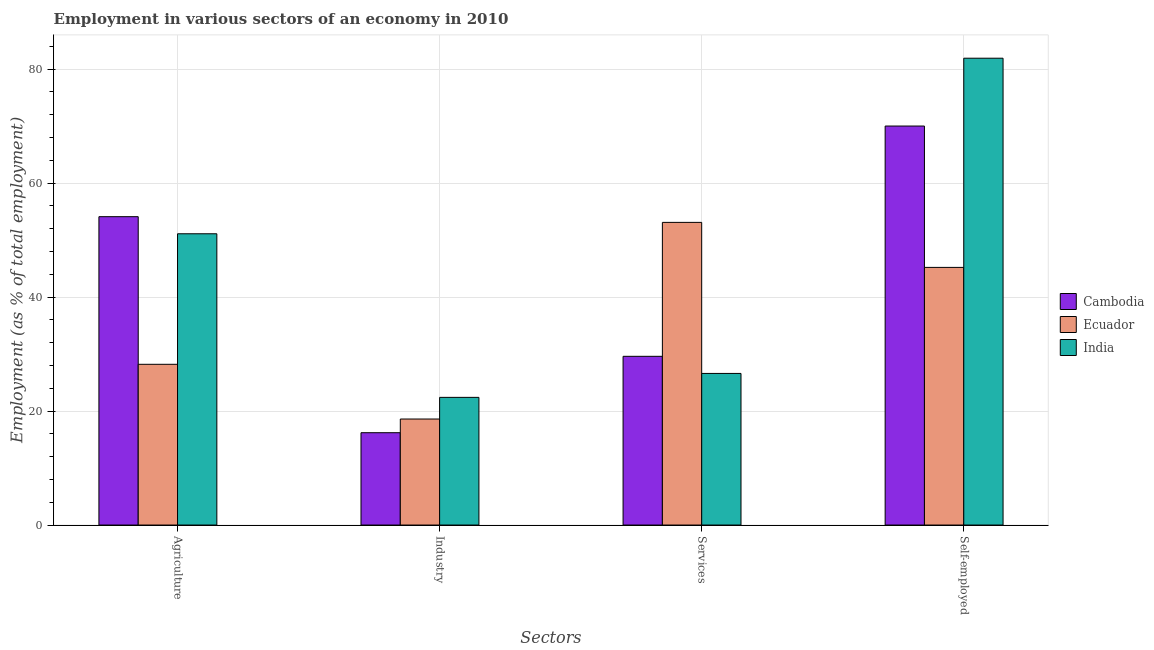How many different coloured bars are there?
Your answer should be very brief. 3. Are the number of bars on each tick of the X-axis equal?
Ensure brevity in your answer.  Yes. How many bars are there on the 1st tick from the left?
Your answer should be compact. 3. What is the label of the 2nd group of bars from the left?
Give a very brief answer. Industry. What is the percentage of self employed workers in Ecuador?
Keep it short and to the point. 45.2. Across all countries, what is the maximum percentage of self employed workers?
Offer a very short reply. 81.9. Across all countries, what is the minimum percentage of self employed workers?
Make the answer very short. 45.2. In which country was the percentage of workers in industry maximum?
Your answer should be very brief. India. In which country was the percentage of self employed workers minimum?
Make the answer very short. Ecuador. What is the total percentage of workers in agriculture in the graph?
Give a very brief answer. 133.4. What is the difference between the percentage of workers in agriculture in Ecuador and that in India?
Keep it short and to the point. -22.9. What is the difference between the percentage of self employed workers in Cambodia and the percentage of workers in industry in Ecuador?
Keep it short and to the point. 51.4. What is the average percentage of workers in agriculture per country?
Keep it short and to the point. 44.47. What is the difference between the percentage of workers in services and percentage of self employed workers in India?
Your answer should be very brief. -55.3. In how many countries, is the percentage of self employed workers greater than 20 %?
Make the answer very short. 3. What is the ratio of the percentage of workers in industry in Cambodia to that in Ecuador?
Provide a succinct answer. 0.87. Is the percentage of workers in agriculture in Cambodia less than that in Ecuador?
Keep it short and to the point. No. What is the difference between the highest and the second highest percentage of workers in agriculture?
Provide a short and direct response. 3. What is the difference between the highest and the lowest percentage of workers in services?
Your response must be concise. 26.5. In how many countries, is the percentage of workers in industry greater than the average percentage of workers in industry taken over all countries?
Your answer should be compact. 1. Is it the case that in every country, the sum of the percentage of workers in services and percentage of self employed workers is greater than the sum of percentage of workers in agriculture and percentage of workers in industry?
Ensure brevity in your answer.  Yes. What does the 3rd bar from the left in Self-employed represents?
Your answer should be very brief. India. Is it the case that in every country, the sum of the percentage of workers in agriculture and percentage of workers in industry is greater than the percentage of workers in services?
Provide a succinct answer. No. How many bars are there?
Provide a short and direct response. 12. How many countries are there in the graph?
Your answer should be very brief. 3. Are the values on the major ticks of Y-axis written in scientific E-notation?
Keep it short and to the point. No. Does the graph contain any zero values?
Your answer should be very brief. No. Does the graph contain grids?
Keep it short and to the point. Yes. Where does the legend appear in the graph?
Your answer should be compact. Center right. How many legend labels are there?
Your answer should be very brief. 3. How are the legend labels stacked?
Your answer should be compact. Vertical. What is the title of the graph?
Offer a very short reply. Employment in various sectors of an economy in 2010. What is the label or title of the X-axis?
Your answer should be compact. Sectors. What is the label or title of the Y-axis?
Provide a short and direct response. Employment (as % of total employment). What is the Employment (as % of total employment) of Cambodia in Agriculture?
Your response must be concise. 54.1. What is the Employment (as % of total employment) in Ecuador in Agriculture?
Your answer should be very brief. 28.2. What is the Employment (as % of total employment) of India in Agriculture?
Your response must be concise. 51.1. What is the Employment (as % of total employment) of Cambodia in Industry?
Ensure brevity in your answer.  16.2. What is the Employment (as % of total employment) of Ecuador in Industry?
Your response must be concise. 18.6. What is the Employment (as % of total employment) of India in Industry?
Give a very brief answer. 22.4. What is the Employment (as % of total employment) in Cambodia in Services?
Offer a very short reply. 29.6. What is the Employment (as % of total employment) in Ecuador in Services?
Your response must be concise. 53.1. What is the Employment (as % of total employment) of India in Services?
Keep it short and to the point. 26.6. What is the Employment (as % of total employment) in Cambodia in Self-employed?
Ensure brevity in your answer.  70. What is the Employment (as % of total employment) in Ecuador in Self-employed?
Make the answer very short. 45.2. What is the Employment (as % of total employment) of India in Self-employed?
Keep it short and to the point. 81.9. Across all Sectors, what is the maximum Employment (as % of total employment) of Ecuador?
Your response must be concise. 53.1. Across all Sectors, what is the maximum Employment (as % of total employment) in India?
Ensure brevity in your answer.  81.9. Across all Sectors, what is the minimum Employment (as % of total employment) of Cambodia?
Keep it short and to the point. 16.2. Across all Sectors, what is the minimum Employment (as % of total employment) of Ecuador?
Offer a terse response. 18.6. Across all Sectors, what is the minimum Employment (as % of total employment) of India?
Keep it short and to the point. 22.4. What is the total Employment (as % of total employment) in Cambodia in the graph?
Your answer should be very brief. 169.9. What is the total Employment (as % of total employment) in Ecuador in the graph?
Offer a terse response. 145.1. What is the total Employment (as % of total employment) in India in the graph?
Give a very brief answer. 182. What is the difference between the Employment (as % of total employment) in Cambodia in Agriculture and that in Industry?
Provide a short and direct response. 37.9. What is the difference between the Employment (as % of total employment) in Ecuador in Agriculture and that in Industry?
Give a very brief answer. 9.6. What is the difference between the Employment (as % of total employment) in India in Agriculture and that in Industry?
Keep it short and to the point. 28.7. What is the difference between the Employment (as % of total employment) of Ecuador in Agriculture and that in Services?
Offer a terse response. -24.9. What is the difference between the Employment (as % of total employment) in Cambodia in Agriculture and that in Self-employed?
Your answer should be compact. -15.9. What is the difference between the Employment (as % of total employment) in Ecuador in Agriculture and that in Self-employed?
Offer a terse response. -17. What is the difference between the Employment (as % of total employment) in India in Agriculture and that in Self-employed?
Give a very brief answer. -30.8. What is the difference between the Employment (as % of total employment) of Ecuador in Industry and that in Services?
Offer a very short reply. -34.5. What is the difference between the Employment (as % of total employment) of Cambodia in Industry and that in Self-employed?
Ensure brevity in your answer.  -53.8. What is the difference between the Employment (as % of total employment) in Ecuador in Industry and that in Self-employed?
Your answer should be very brief. -26.6. What is the difference between the Employment (as % of total employment) in India in Industry and that in Self-employed?
Make the answer very short. -59.5. What is the difference between the Employment (as % of total employment) in Cambodia in Services and that in Self-employed?
Provide a short and direct response. -40.4. What is the difference between the Employment (as % of total employment) in Ecuador in Services and that in Self-employed?
Your answer should be very brief. 7.9. What is the difference between the Employment (as % of total employment) of India in Services and that in Self-employed?
Give a very brief answer. -55.3. What is the difference between the Employment (as % of total employment) of Cambodia in Agriculture and the Employment (as % of total employment) of Ecuador in Industry?
Ensure brevity in your answer.  35.5. What is the difference between the Employment (as % of total employment) of Cambodia in Agriculture and the Employment (as % of total employment) of India in Industry?
Make the answer very short. 31.7. What is the difference between the Employment (as % of total employment) in Cambodia in Agriculture and the Employment (as % of total employment) in Ecuador in Services?
Provide a short and direct response. 1. What is the difference between the Employment (as % of total employment) in Cambodia in Agriculture and the Employment (as % of total employment) in India in Self-employed?
Make the answer very short. -27.8. What is the difference between the Employment (as % of total employment) in Ecuador in Agriculture and the Employment (as % of total employment) in India in Self-employed?
Offer a very short reply. -53.7. What is the difference between the Employment (as % of total employment) in Cambodia in Industry and the Employment (as % of total employment) in Ecuador in Services?
Provide a short and direct response. -36.9. What is the difference between the Employment (as % of total employment) of Cambodia in Industry and the Employment (as % of total employment) of Ecuador in Self-employed?
Provide a short and direct response. -29. What is the difference between the Employment (as % of total employment) in Cambodia in Industry and the Employment (as % of total employment) in India in Self-employed?
Your answer should be very brief. -65.7. What is the difference between the Employment (as % of total employment) in Ecuador in Industry and the Employment (as % of total employment) in India in Self-employed?
Give a very brief answer. -63.3. What is the difference between the Employment (as % of total employment) of Cambodia in Services and the Employment (as % of total employment) of Ecuador in Self-employed?
Provide a short and direct response. -15.6. What is the difference between the Employment (as % of total employment) of Cambodia in Services and the Employment (as % of total employment) of India in Self-employed?
Provide a short and direct response. -52.3. What is the difference between the Employment (as % of total employment) of Ecuador in Services and the Employment (as % of total employment) of India in Self-employed?
Your response must be concise. -28.8. What is the average Employment (as % of total employment) in Cambodia per Sectors?
Offer a very short reply. 42.48. What is the average Employment (as % of total employment) of Ecuador per Sectors?
Provide a short and direct response. 36.27. What is the average Employment (as % of total employment) of India per Sectors?
Keep it short and to the point. 45.5. What is the difference between the Employment (as % of total employment) in Cambodia and Employment (as % of total employment) in Ecuador in Agriculture?
Your answer should be compact. 25.9. What is the difference between the Employment (as % of total employment) of Cambodia and Employment (as % of total employment) of India in Agriculture?
Provide a succinct answer. 3. What is the difference between the Employment (as % of total employment) of Ecuador and Employment (as % of total employment) of India in Agriculture?
Make the answer very short. -22.9. What is the difference between the Employment (as % of total employment) of Cambodia and Employment (as % of total employment) of Ecuador in Industry?
Make the answer very short. -2.4. What is the difference between the Employment (as % of total employment) in Cambodia and Employment (as % of total employment) in Ecuador in Services?
Your answer should be very brief. -23.5. What is the difference between the Employment (as % of total employment) of Cambodia and Employment (as % of total employment) of India in Services?
Offer a very short reply. 3. What is the difference between the Employment (as % of total employment) in Cambodia and Employment (as % of total employment) in Ecuador in Self-employed?
Keep it short and to the point. 24.8. What is the difference between the Employment (as % of total employment) of Ecuador and Employment (as % of total employment) of India in Self-employed?
Provide a short and direct response. -36.7. What is the ratio of the Employment (as % of total employment) in Cambodia in Agriculture to that in Industry?
Make the answer very short. 3.34. What is the ratio of the Employment (as % of total employment) in Ecuador in Agriculture to that in Industry?
Ensure brevity in your answer.  1.52. What is the ratio of the Employment (as % of total employment) in India in Agriculture to that in Industry?
Your answer should be very brief. 2.28. What is the ratio of the Employment (as % of total employment) in Cambodia in Agriculture to that in Services?
Your answer should be compact. 1.83. What is the ratio of the Employment (as % of total employment) in Ecuador in Agriculture to that in Services?
Keep it short and to the point. 0.53. What is the ratio of the Employment (as % of total employment) in India in Agriculture to that in Services?
Offer a terse response. 1.92. What is the ratio of the Employment (as % of total employment) of Cambodia in Agriculture to that in Self-employed?
Your answer should be very brief. 0.77. What is the ratio of the Employment (as % of total employment) in Ecuador in Agriculture to that in Self-employed?
Your answer should be very brief. 0.62. What is the ratio of the Employment (as % of total employment) in India in Agriculture to that in Self-employed?
Ensure brevity in your answer.  0.62. What is the ratio of the Employment (as % of total employment) in Cambodia in Industry to that in Services?
Offer a very short reply. 0.55. What is the ratio of the Employment (as % of total employment) in Ecuador in Industry to that in Services?
Provide a short and direct response. 0.35. What is the ratio of the Employment (as % of total employment) of India in Industry to that in Services?
Ensure brevity in your answer.  0.84. What is the ratio of the Employment (as % of total employment) in Cambodia in Industry to that in Self-employed?
Offer a very short reply. 0.23. What is the ratio of the Employment (as % of total employment) in Ecuador in Industry to that in Self-employed?
Your answer should be compact. 0.41. What is the ratio of the Employment (as % of total employment) in India in Industry to that in Self-employed?
Make the answer very short. 0.27. What is the ratio of the Employment (as % of total employment) of Cambodia in Services to that in Self-employed?
Your answer should be compact. 0.42. What is the ratio of the Employment (as % of total employment) of Ecuador in Services to that in Self-employed?
Keep it short and to the point. 1.17. What is the ratio of the Employment (as % of total employment) in India in Services to that in Self-employed?
Your answer should be very brief. 0.32. What is the difference between the highest and the second highest Employment (as % of total employment) of India?
Offer a terse response. 30.8. What is the difference between the highest and the lowest Employment (as % of total employment) in Cambodia?
Your response must be concise. 53.8. What is the difference between the highest and the lowest Employment (as % of total employment) of Ecuador?
Your response must be concise. 34.5. What is the difference between the highest and the lowest Employment (as % of total employment) of India?
Provide a short and direct response. 59.5. 